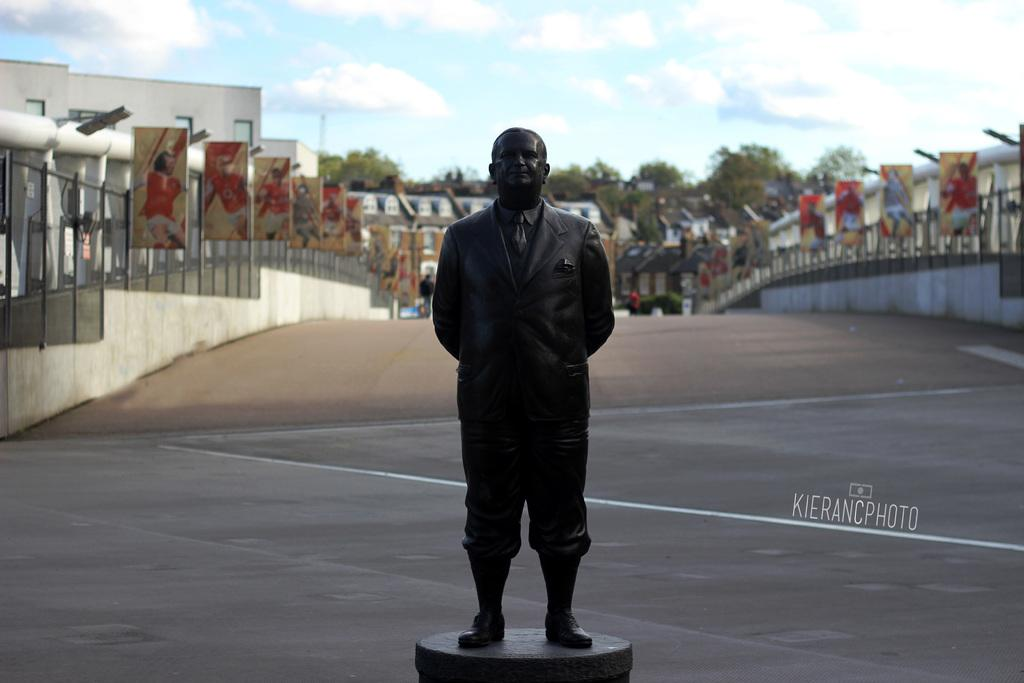What is the main subject in the middle of the image? There is a statue in the middle of the image. What else can be seen in the middle of the image besides the statue? There are trees in the middle of the image. What is visible at the top of the image? The sky is visible at the top of the image. What type of structures can be seen on the left side of the image? There are buildings on the left side of the image. What type of structures can be seen on the right side of the image? There are buildings on the right side of the image. Can you tell me how many times your aunt visited the hospital in the image? There is no mention of an aunt or a hospital in the image; it features a statue, trees, the sky, and buildings. 